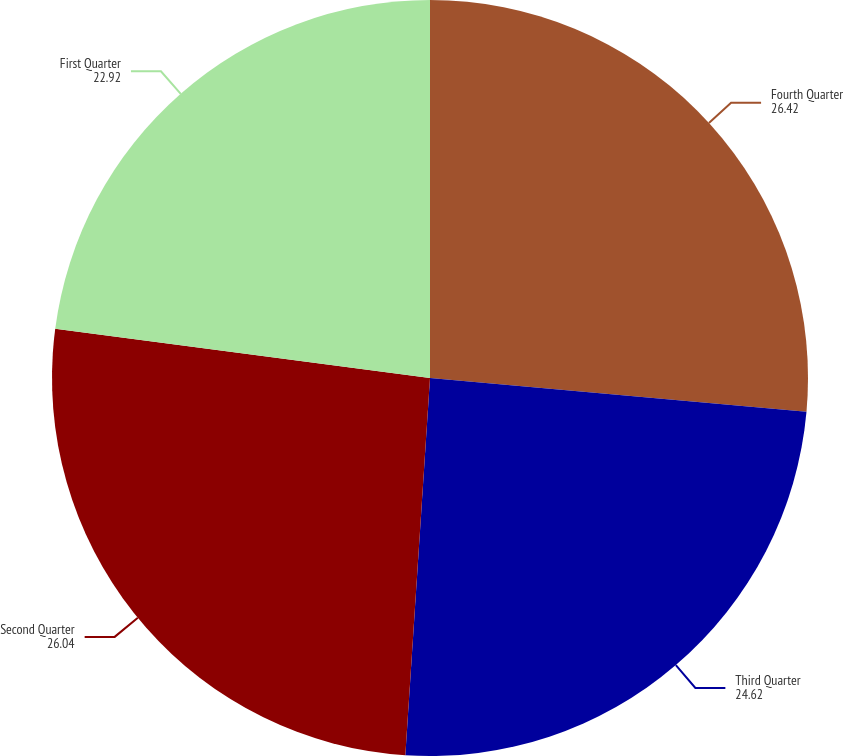Convert chart to OTSL. <chart><loc_0><loc_0><loc_500><loc_500><pie_chart><fcel>Fourth Quarter<fcel>Third Quarter<fcel>Second Quarter<fcel>First Quarter<nl><fcel>26.42%<fcel>24.62%<fcel>26.04%<fcel>22.92%<nl></chart> 